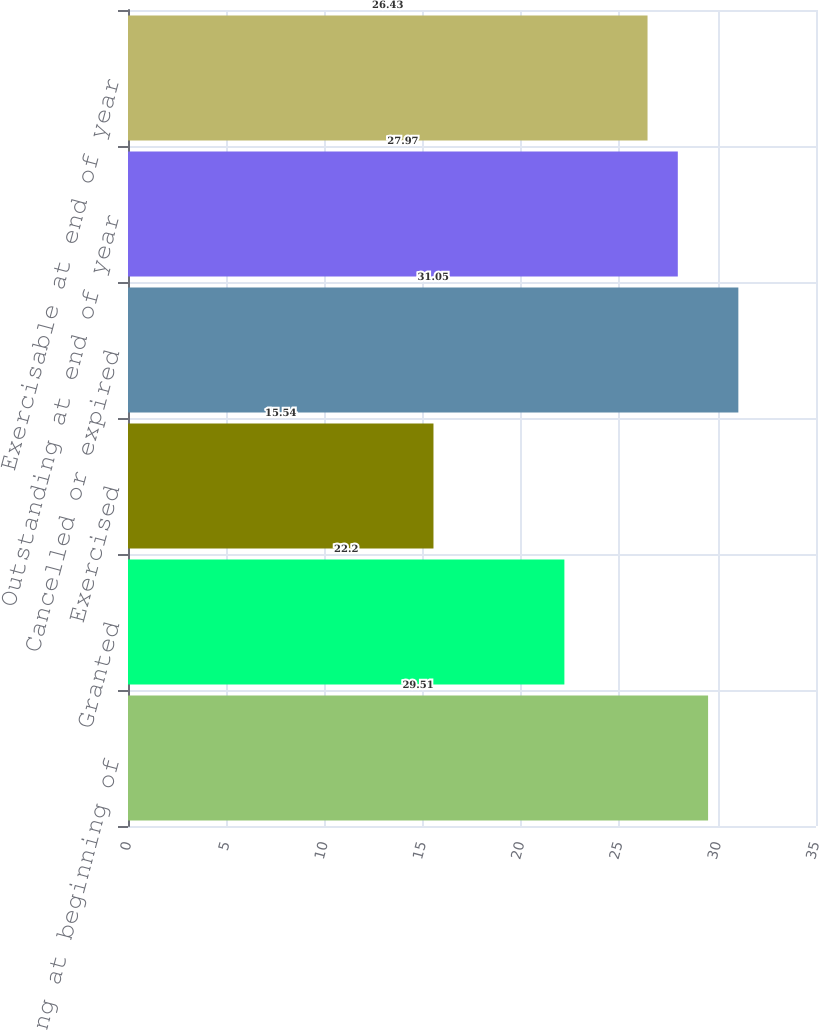Convert chart. <chart><loc_0><loc_0><loc_500><loc_500><bar_chart><fcel>Outstanding at beginning of<fcel>Granted<fcel>Exercised<fcel>Cancelled or expired<fcel>Outstanding at end of year<fcel>Exercisable at end of year<nl><fcel>29.51<fcel>22.2<fcel>15.54<fcel>31.05<fcel>27.97<fcel>26.43<nl></chart> 